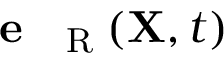Convert formula to latex. <formula><loc_0><loc_0><loc_500><loc_500>e _ { R } ( { X } , t )</formula> 